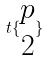Convert formula to latex. <formula><loc_0><loc_0><loc_500><loc_500>t \{ \begin{matrix} p \\ 2 \end{matrix} \}</formula> 